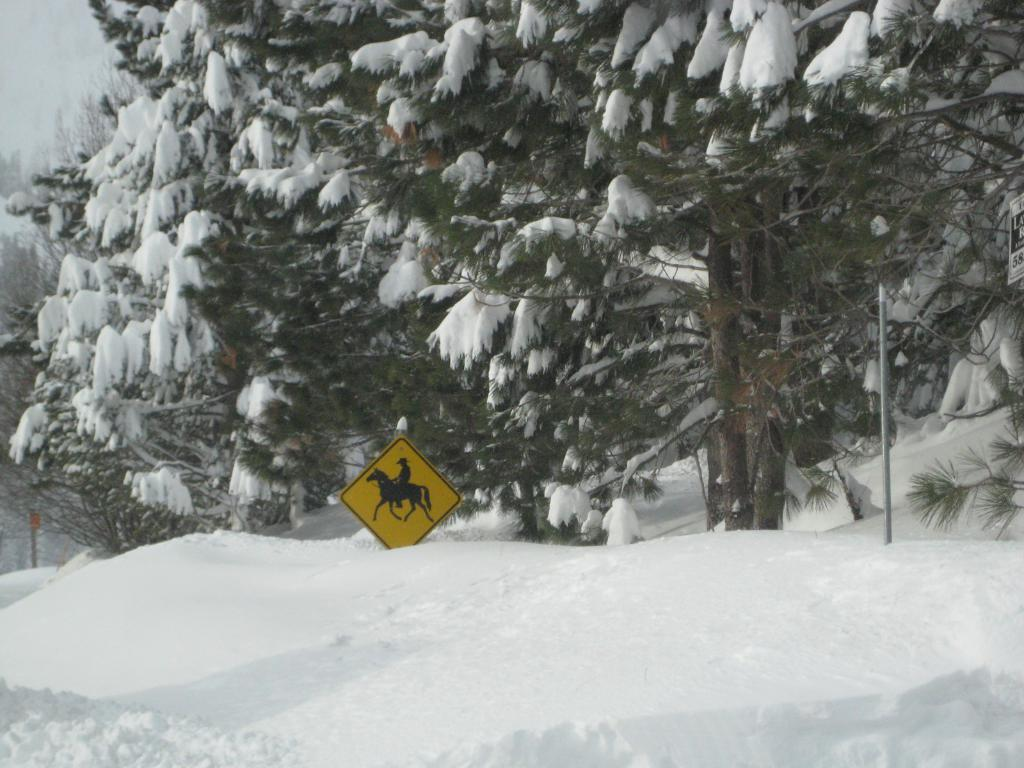What type of vegetation can be seen in the image? There are trees in the image. How are the trees in the image affected by the weather? The trees are fully covered with snow. Can you describe any other objects in the image besides the trees? There is a yellow board in the image. How many lizards are sitting on the yellow board in the image? There are no lizards present in the image; it only features trees covered in snow and a yellow board. 